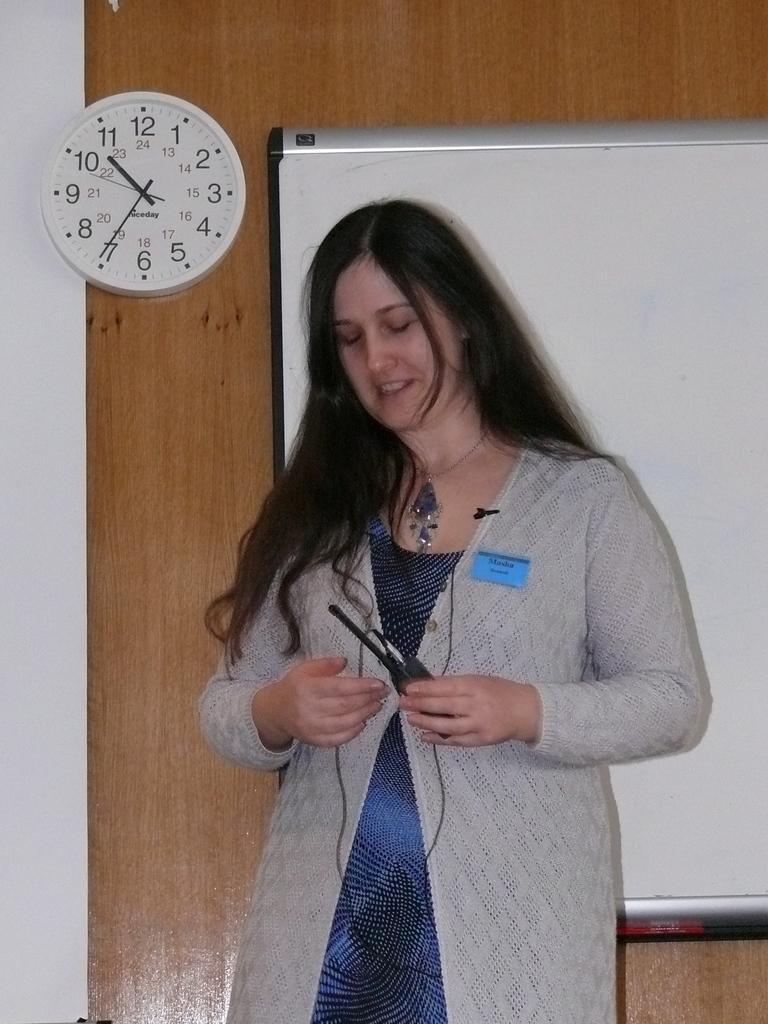How would you summarize this image in a sentence or two? There is one woman standing and holding an object as we can see in the middle of this image. There is a wall in the background. We can see a white board on the right side of this image and there is a clock on the left side of this image. 